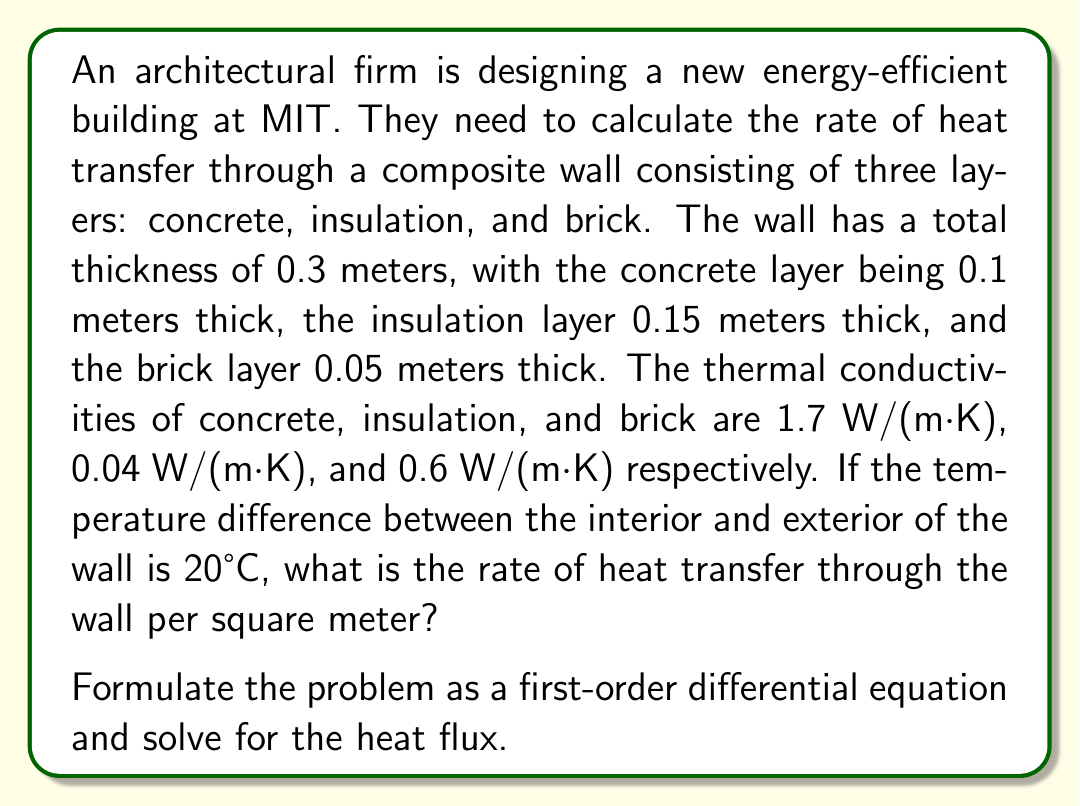Teach me how to tackle this problem. To solve this problem, we'll use Fourier's law of heat conduction and treat the wall as a series of thermal resistances. Let's approach this step-by-step:

1) Fourier's law of heat conduction in one dimension is given by:

   $$q = -k \frac{dT}{dx}$$

   where $q$ is the heat flux, $k$ is the thermal conductivity, and $\frac{dT}{dx}$ is the temperature gradient.

2) For a composite wall, we can express the total thermal resistance as the sum of individual layer resistances:

   $$R_{total} = R_1 + R_2 + R_3 = \frac{L_1}{k_1} + \frac{L_2}{k_2} + \frac{L_3}{k_3}$$

   where $L_i$ is the thickness of each layer and $k_i$ is its thermal conductivity.

3) Let's calculate the thermal resistance for each layer:

   Concrete: $R_1 = \frac{0.1}{1.7} = 0.0588$ m²·K/W
   Insulation: $R_2 = \frac{0.15}{0.04} = 3.75$ m²·K/W
   Brick: $R_3 = \frac{0.05}{0.6} = 0.0833$ m²·K/W

4) The total thermal resistance is:

   $$R_{total} = 0.0588 + 3.75 + 0.0833 = 3.8921$ m²·K/W

5) Now, we can use the steady-state heat transfer equation:

   $$q = \frac{\Delta T}{R_{total}}$$

   where $\Delta T$ is the temperature difference across the wall.

6) Substituting the values:

   $$q = \frac{20}{3.8921} = 5.1386$ W/m²

Therefore, the rate of heat transfer through the wall is approximately 5.14 W/m².
Answer: The rate of heat transfer through the composite wall is approximately 5.14 W/m². 